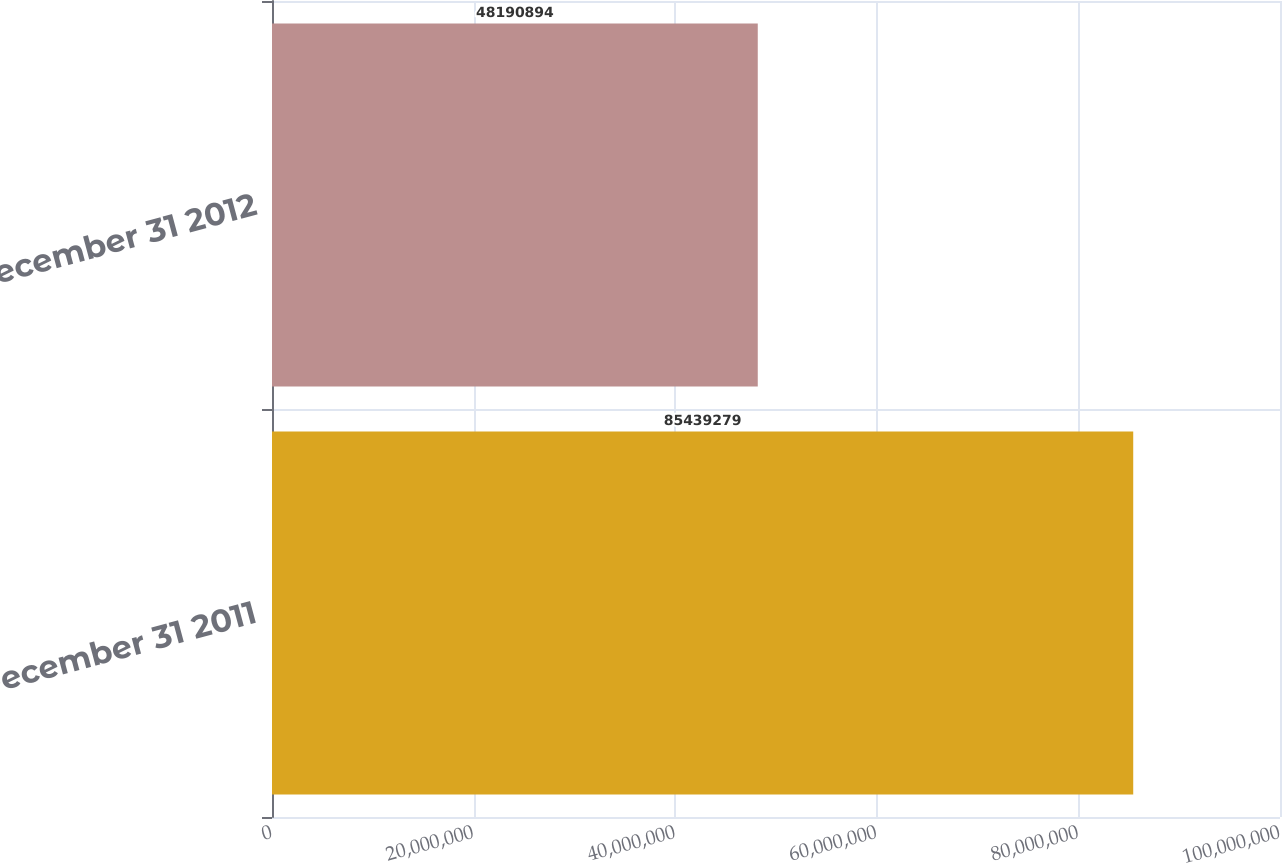<chart> <loc_0><loc_0><loc_500><loc_500><bar_chart><fcel>December 31 2011<fcel>December 31 2012<nl><fcel>8.54393e+07<fcel>4.81909e+07<nl></chart> 